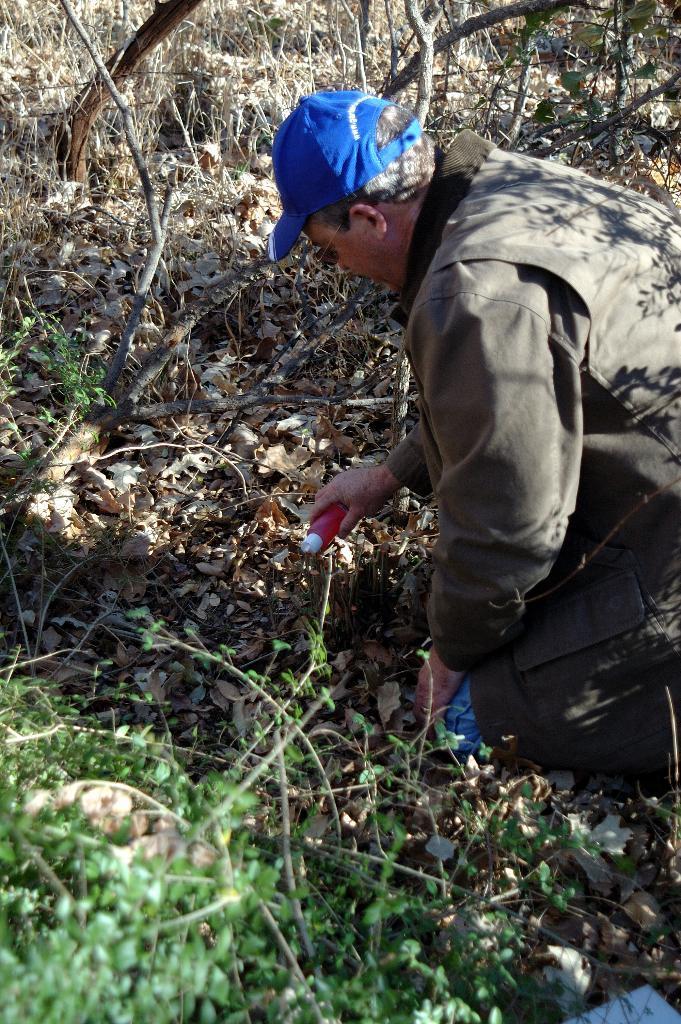Could you give a brief overview of what you see in this image? In this image there is a person wearing a cap and holding an object, there are few leaves on the ground, few trees and plants. 